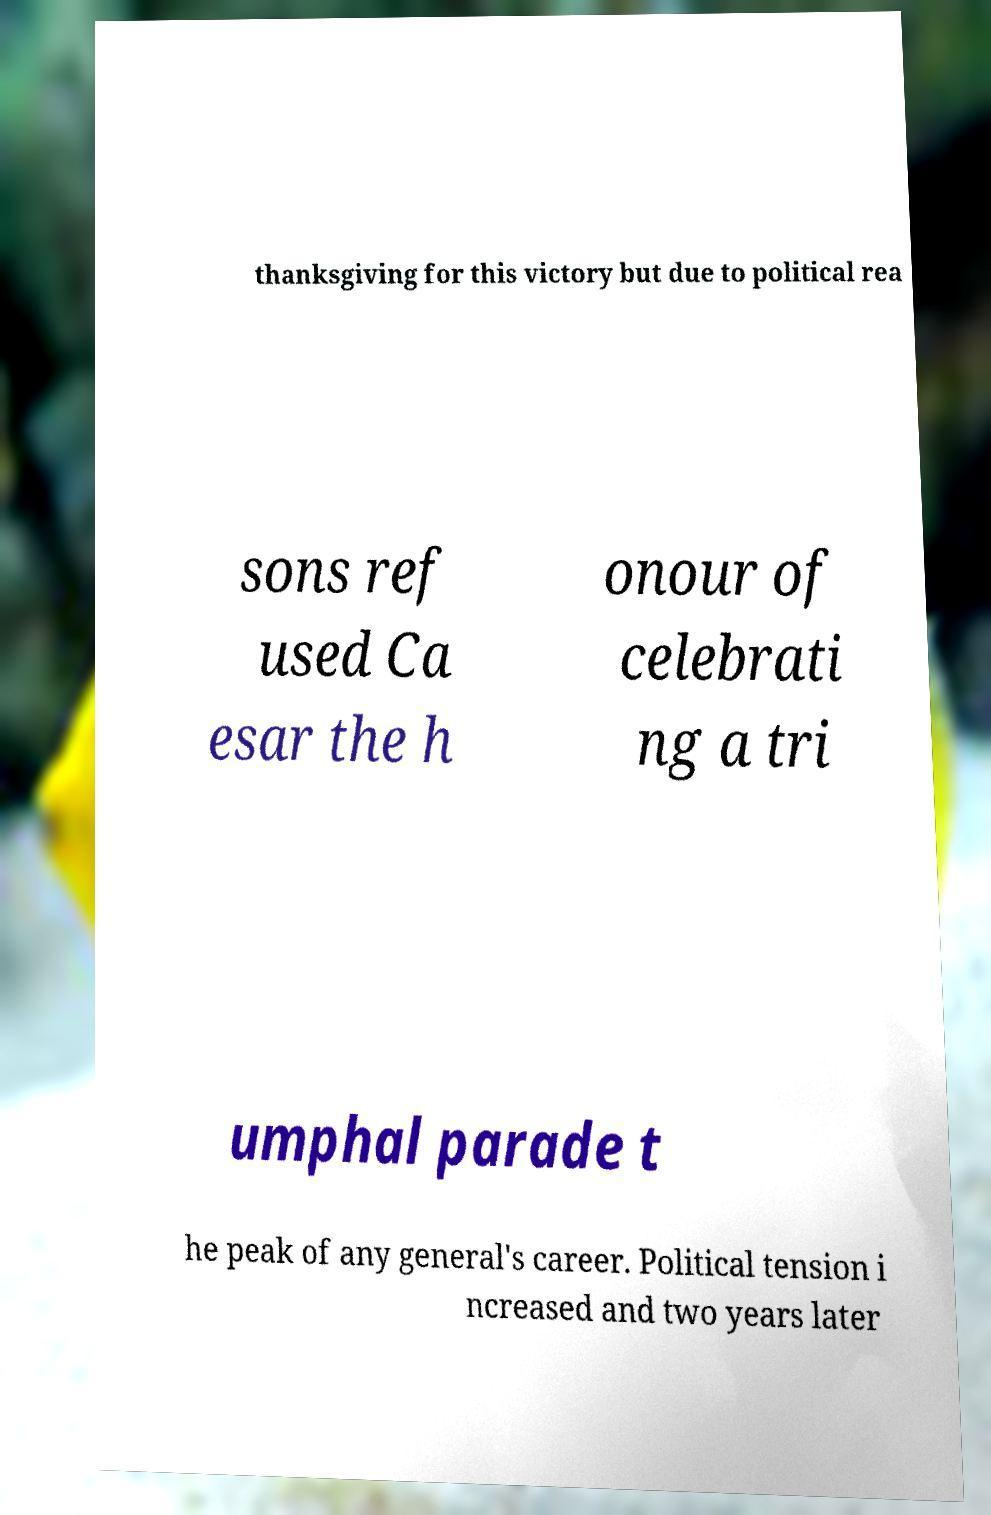I need the written content from this picture converted into text. Can you do that? thanksgiving for this victory but due to political rea sons ref used Ca esar the h onour of celebrati ng a tri umphal parade t he peak of any general's career. Political tension i ncreased and two years later 